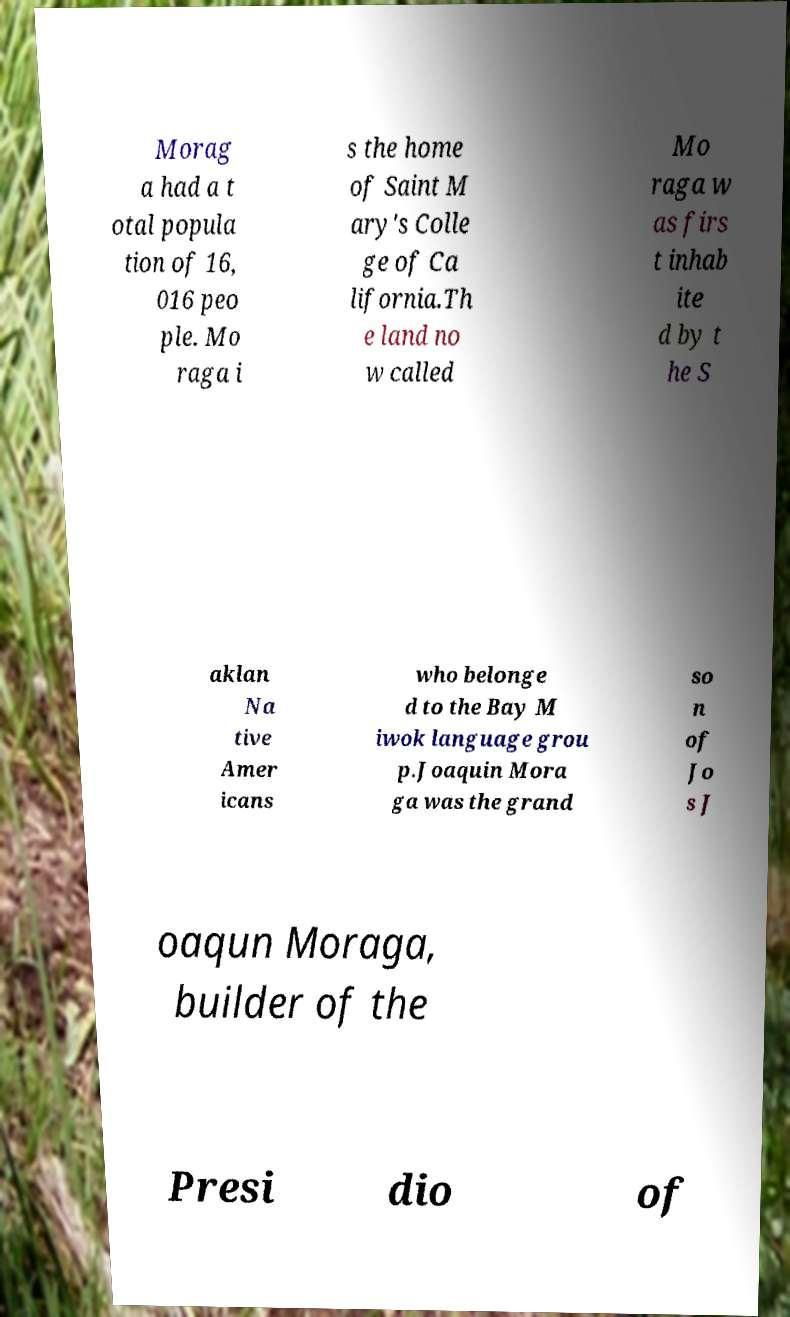Please read and relay the text visible in this image. What does it say? Morag a had a t otal popula tion of 16, 016 peo ple. Mo raga i s the home of Saint M ary's Colle ge of Ca lifornia.Th e land no w called Mo raga w as firs t inhab ite d by t he S aklan Na tive Amer icans who belonge d to the Bay M iwok language grou p.Joaquin Mora ga was the grand so n of Jo s J oaqun Moraga, builder of the Presi dio of 